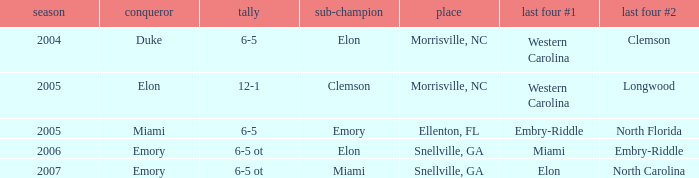When Embry-Riddle made it to the first semi finalist slot, list all the runners up. Emory. 